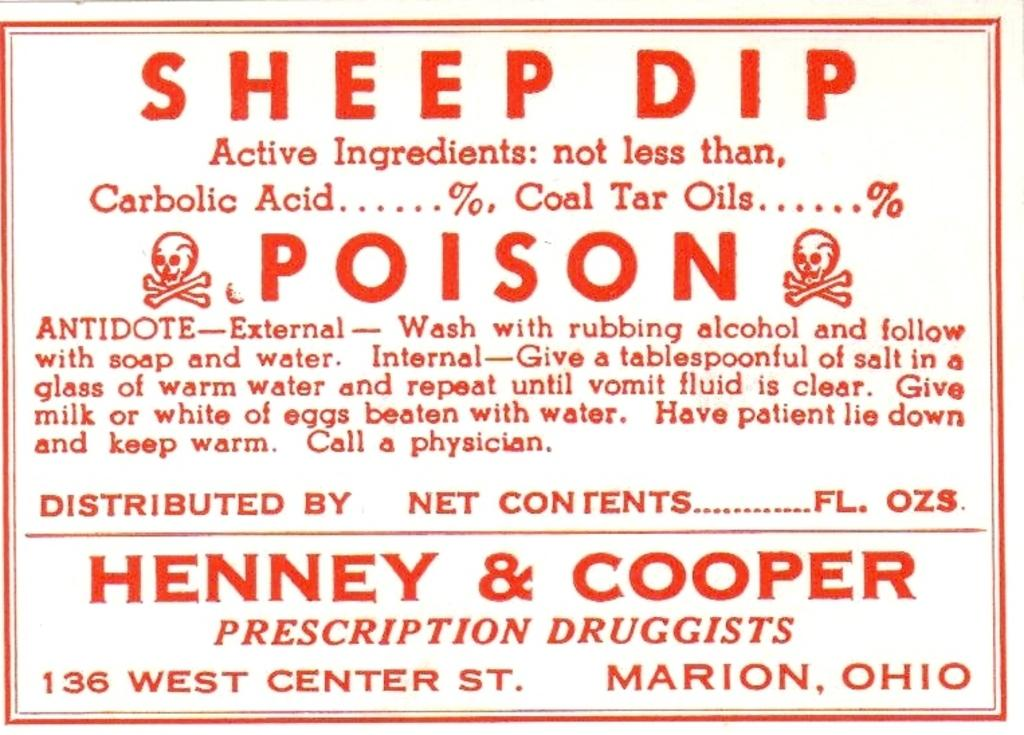<image>
Describe the image concisely. An old fashioned label with red text that says Sheep Dip by Henney & Cooper. 